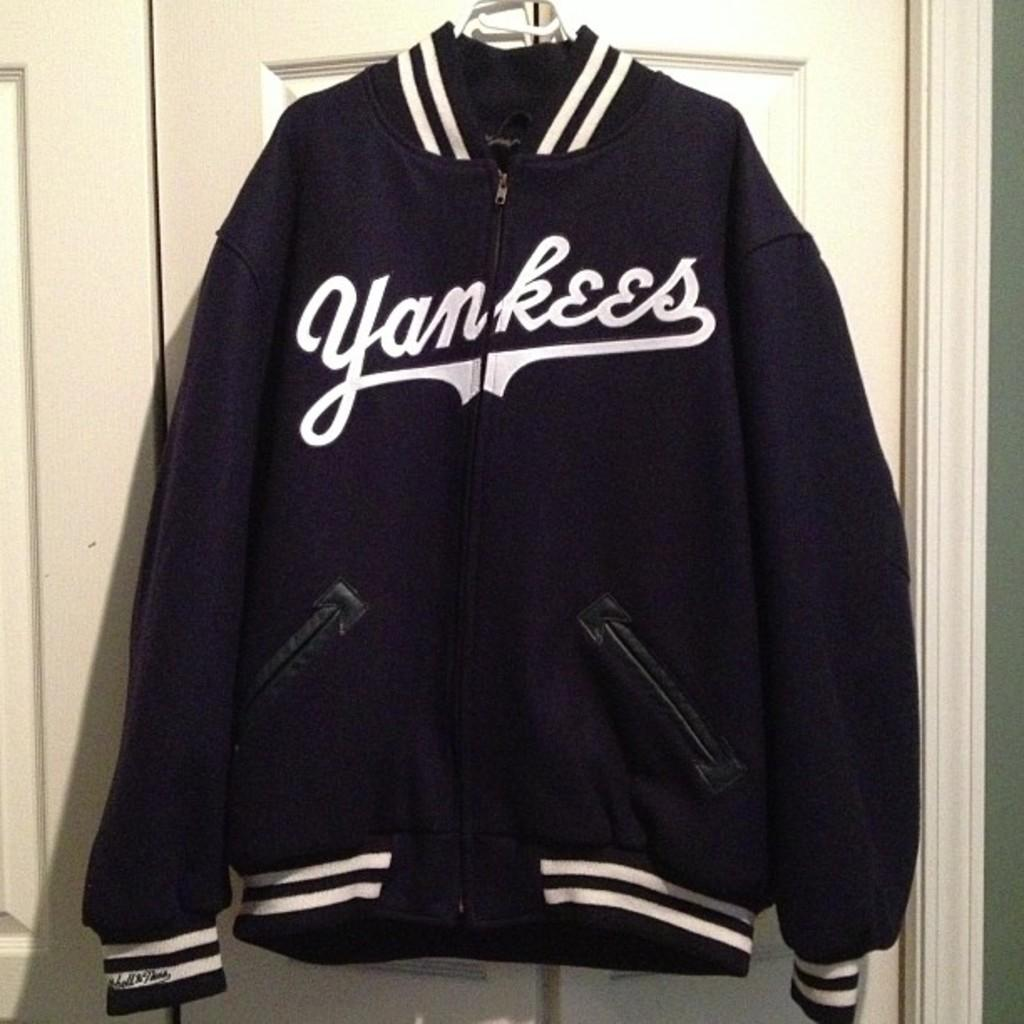<image>
Provide a brief description of the given image. A black Yankees jacket with white strips on the sleeves and on the bottom of the jacket. 